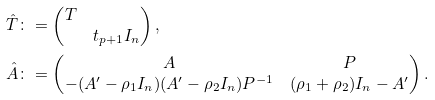<formula> <loc_0><loc_0><loc_500><loc_500>\hat { T } & \colon = \begin{pmatrix} T \\ & t _ { p + 1 } I _ { n } \end{pmatrix} , \\ \hat { A } & \colon = \begin{pmatrix} A & P \\ - ( A ^ { \prime } - \rho _ { 1 } I _ { n } ) ( A ^ { \prime } - \rho _ { 2 } I _ { n } ) P ^ { - 1 } & ( \rho _ { 1 } + \rho _ { 2 } ) I _ { n } - A ^ { \prime } \end{pmatrix} .</formula> 